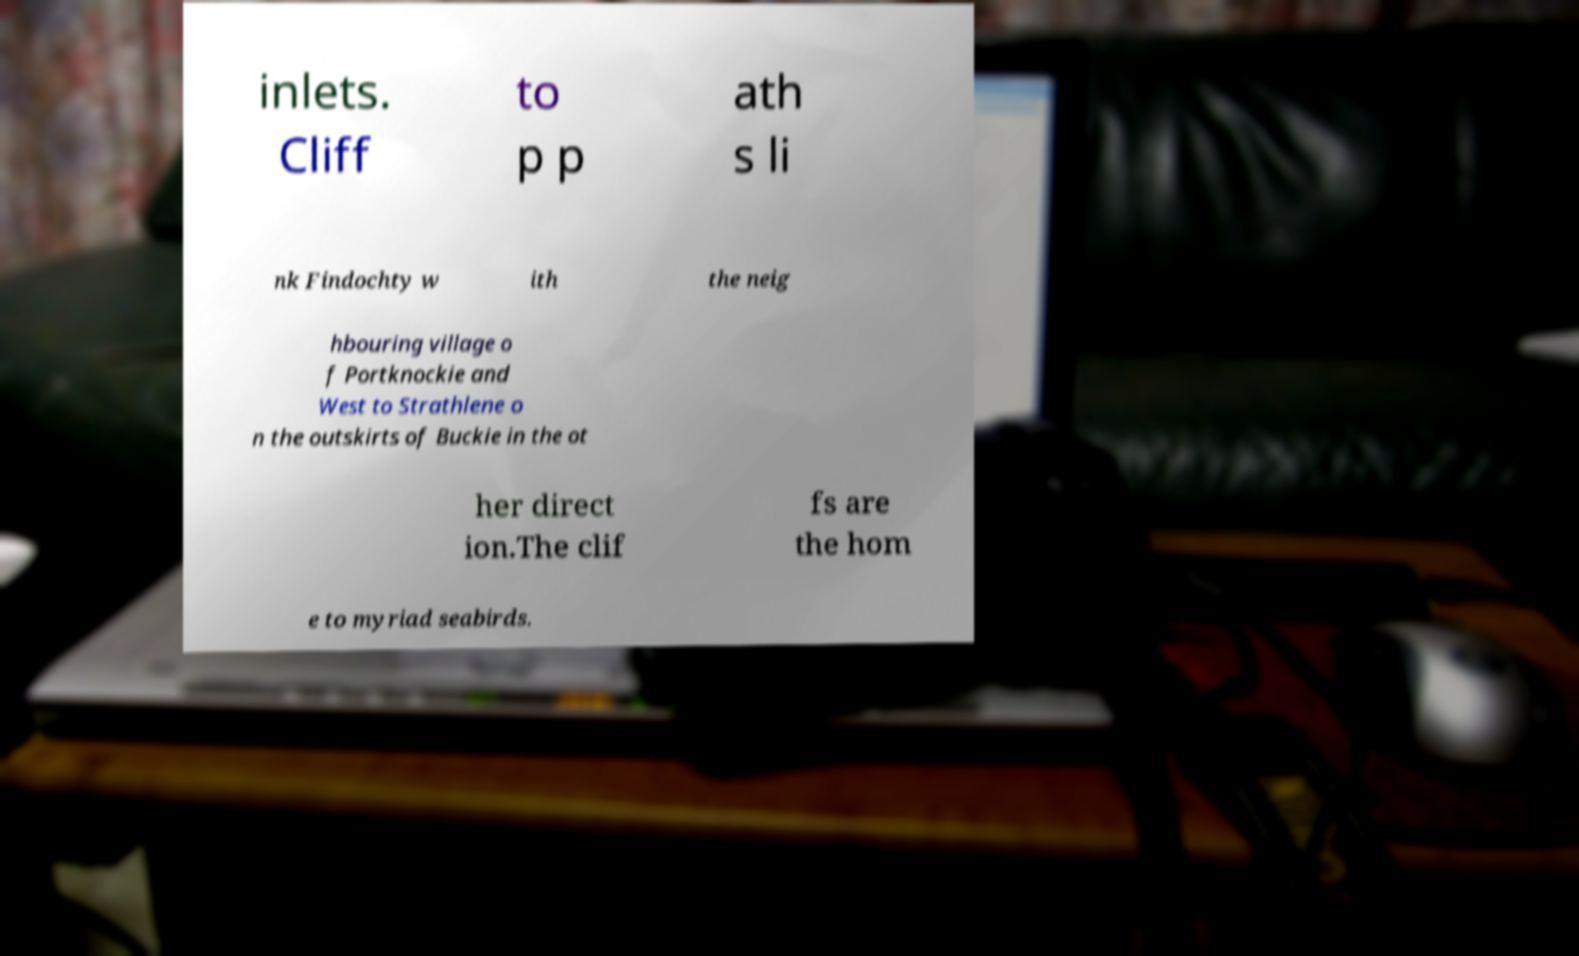Could you assist in decoding the text presented in this image and type it out clearly? inlets. Cliff to p p ath s li nk Findochty w ith the neig hbouring village o f Portknockie and West to Strathlene o n the outskirts of Buckie in the ot her direct ion.The clif fs are the hom e to myriad seabirds. 